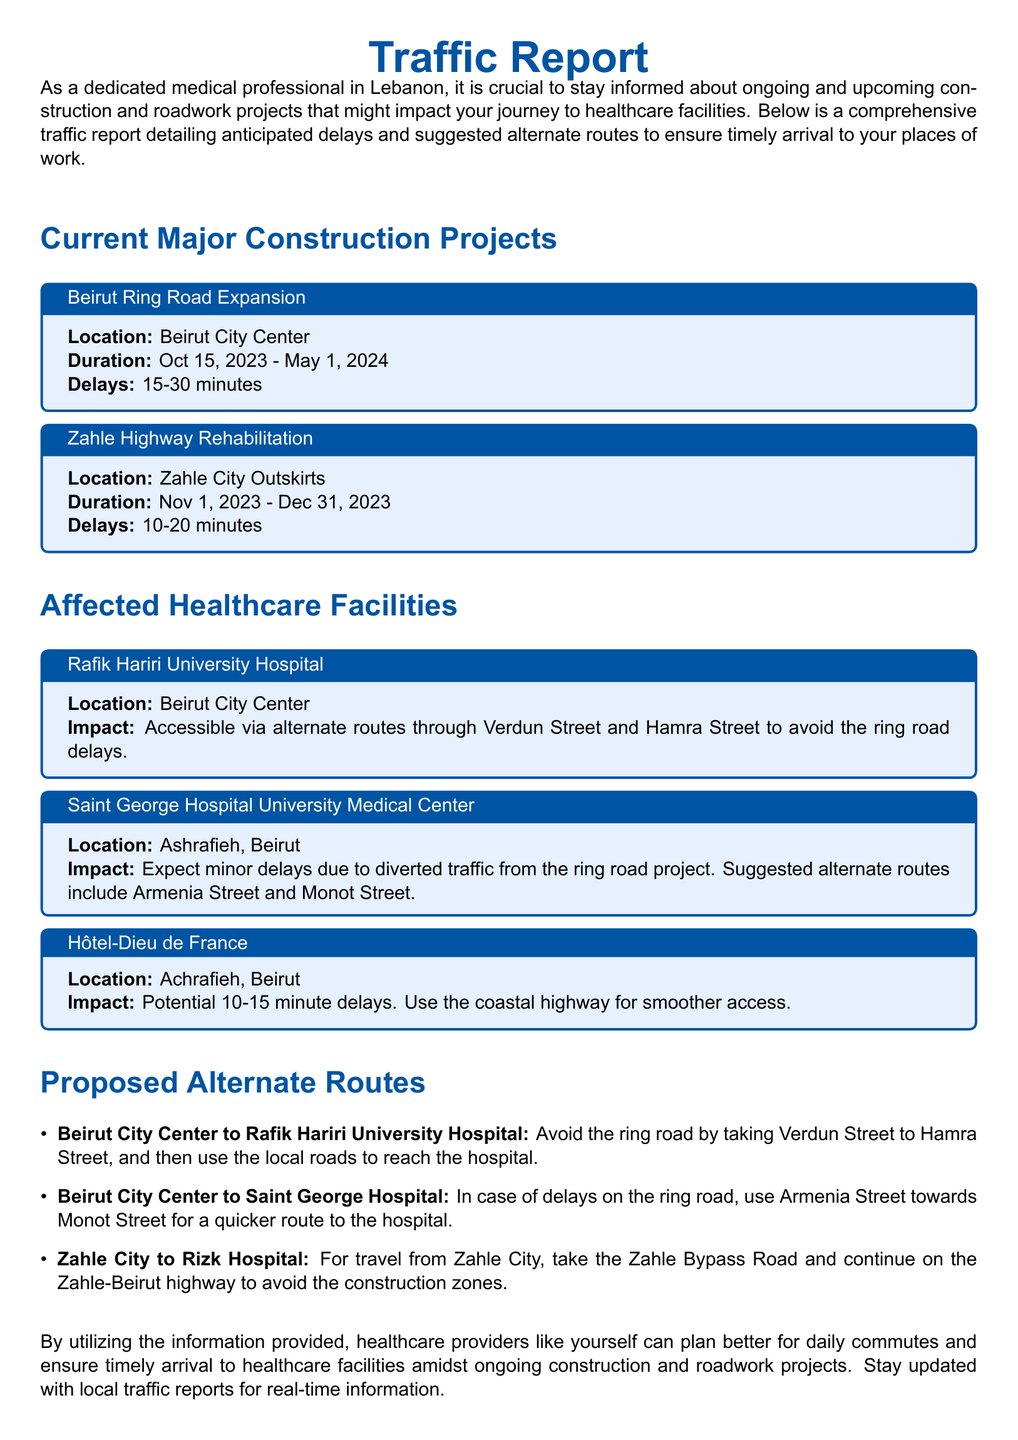What is the location of the Beirut Ring Road Expansion project? The document specifies the location of the Beirut Ring Road Expansion project as Beirut City Center.
Answer: Beirut City Center What is the duration of the Zahle Highway Rehabilitation project? According to the document, the duration of the Zahle Highway Rehabilitation project is from Nov 1, 2023, to Dec 31, 2023.
Answer: Nov 1, 2023 - Dec 31, 2023 What is the expected delay for access to Rafik Hariri University Hospital? The document indicates that access to Rafik Hariri University Hospital is expected to have delays of 15-30 minutes due to ongoing construction.
Answer: 15-30 minutes Which alternate route is suggested for Rafik Hariri University Hospital? The document recommends using Verdun Street and Hamra Street to avoid delays at the ring road for accessing Rafik Hariri University Hospital.
Answer: Verdun Street and Hamra Street What is the impact of the ring road project on Saint George Hospital? It states that Saint George Hospital is expected to experience minor delays due to diverted traffic from the ring road project.
Answer: Minor delays How can one travel from Zahle City to Rizk Hospital? The document suggests taking the Zahle Bypass Road and continuing on the Zahle-Beirut highway to avoid construction zones when traveling from Zahle City to Rizk Hospital.
Answer: Zahle Bypass Road What is the anticipated delay for Hôtel-Dieu de France? The anticipated delay for Hôtel-Dieu de France is specified in the document as 10-15 minutes.
Answer: 10-15 minutes What is the impact of ongoing construction on healthcare providers? According to the document, healthcare providers are encouraged to stay updated for timely arrival due to ongoing construction affecting their commutes.
Answer: Timely arrival 